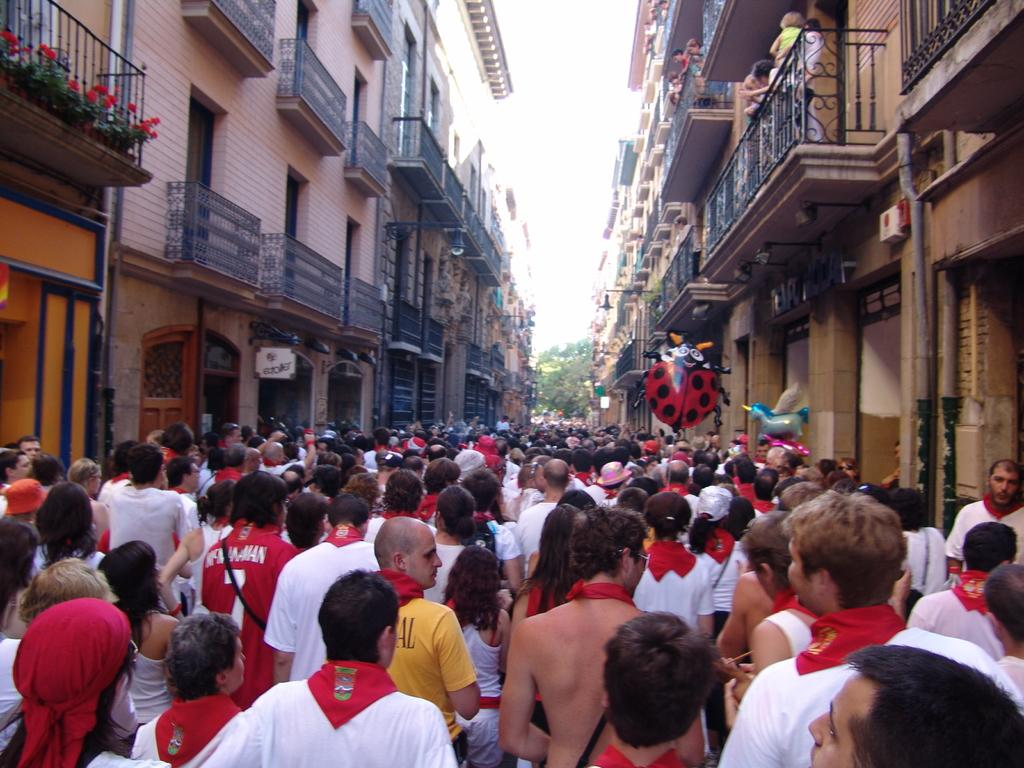How many people are present in the image? There are many people in the image. What can be seen in the background of the image? There are buildings, railings, flower pots, balloons, poles, boards, and trees visible in the background. What type of celery is being used to rate the beds in the image? There is no celery or beds present in the image, and therefore no such activity can be observed. 